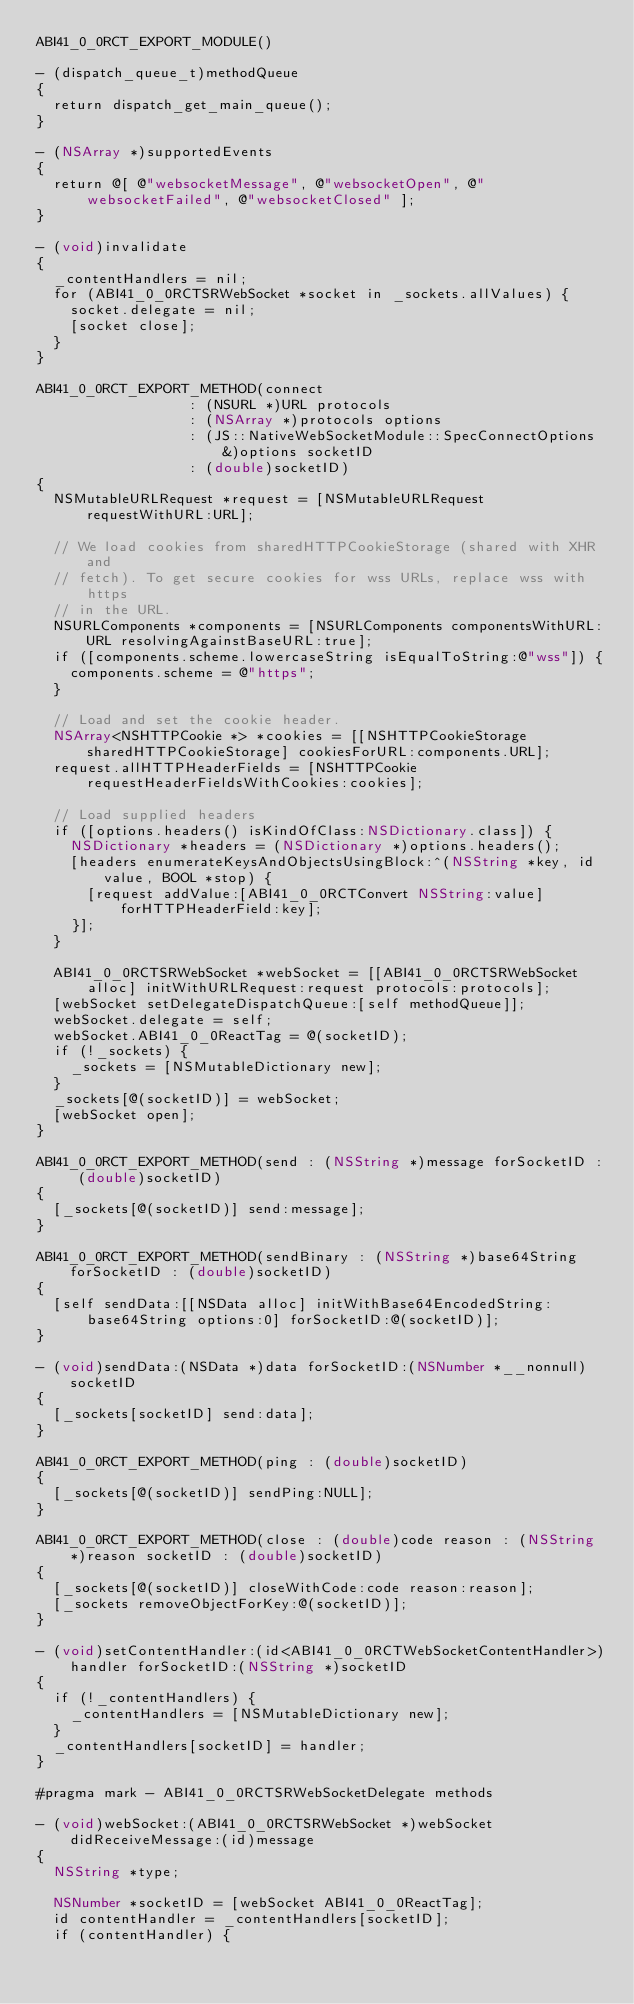Convert code to text. <code><loc_0><loc_0><loc_500><loc_500><_ObjectiveC_>ABI41_0_0RCT_EXPORT_MODULE()

- (dispatch_queue_t)methodQueue
{
  return dispatch_get_main_queue();
}

- (NSArray *)supportedEvents
{
  return @[ @"websocketMessage", @"websocketOpen", @"websocketFailed", @"websocketClosed" ];
}

- (void)invalidate
{
  _contentHandlers = nil;
  for (ABI41_0_0RCTSRWebSocket *socket in _sockets.allValues) {
    socket.delegate = nil;
    [socket close];
  }
}

ABI41_0_0RCT_EXPORT_METHOD(connect
                  : (NSURL *)URL protocols
                  : (NSArray *)protocols options
                  : (JS::NativeWebSocketModule::SpecConnectOptions &)options socketID
                  : (double)socketID)
{
  NSMutableURLRequest *request = [NSMutableURLRequest requestWithURL:URL];

  // We load cookies from sharedHTTPCookieStorage (shared with XHR and
  // fetch). To get secure cookies for wss URLs, replace wss with https
  // in the URL.
  NSURLComponents *components = [NSURLComponents componentsWithURL:URL resolvingAgainstBaseURL:true];
  if ([components.scheme.lowercaseString isEqualToString:@"wss"]) {
    components.scheme = @"https";
  }

  // Load and set the cookie header.
  NSArray<NSHTTPCookie *> *cookies = [[NSHTTPCookieStorage sharedHTTPCookieStorage] cookiesForURL:components.URL];
  request.allHTTPHeaderFields = [NSHTTPCookie requestHeaderFieldsWithCookies:cookies];

  // Load supplied headers
  if ([options.headers() isKindOfClass:NSDictionary.class]) {
    NSDictionary *headers = (NSDictionary *)options.headers();
    [headers enumerateKeysAndObjectsUsingBlock:^(NSString *key, id value, BOOL *stop) {
      [request addValue:[ABI41_0_0RCTConvert NSString:value] forHTTPHeaderField:key];
    }];
  }

  ABI41_0_0RCTSRWebSocket *webSocket = [[ABI41_0_0RCTSRWebSocket alloc] initWithURLRequest:request protocols:protocols];
  [webSocket setDelegateDispatchQueue:[self methodQueue]];
  webSocket.delegate = self;
  webSocket.ABI41_0_0ReactTag = @(socketID);
  if (!_sockets) {
    _sockets = [NSMutableDictionary new];
  }
  _sockets[@(socketID)] = webSocket;
  [webSocket open];
}

ABI41_0_0RCT_EXPORT_METHOD(send : (NSString *)message forSocketID : (double)socketID)
{
  [_sockets[@(socketID)] send:message];
}

ABI41_0_0RCT_EXPORT_METHOD(sendBinary : (NSString *)base64String forSocketID : (double)socketID)
{
  [self sendData:[[NSData alloc] initWithBase64EncodedString:base64String options:0] forSocketID:@(socketID)];
}

- (void)sendData:(NSData *)data forSocketID:(NSNumber *__nonnull)socketID
{
  [_sockets[socketID] send:data];
}

ABI41_0_0RCT_EXPORT_METHOD(ping : (double)socketID)
{
  [_sockets[@(socketID)] sendPing:NULL];
}

ABI41_0_0RCT_EXPORT_METHOD(close : (double)code reason : (NSString *)reason socketID : (double)socketID)
{
  [_sockets[@(socketID)] closeWithCode:code reason:reason];
  [_sockets removeObjectForKey:@(socketID)];
}

- (void)setContentHandler:(id<ABI41_0_0RCTWebSocketContentHandler>)handler forSocketID:(NSString *)socketID
{
  if (!_contentHandlers) {
    _contentHandlers = [NSMutableDictionary new];
  }
  _contentHandlers[socketID] = handler;
}

#pragma mark - ABI41_0_0RCTSRWebSocketDelegate methods

- (void)webSocket:(ABI41_0_0RCTSRWebSocket *)webSocket didReceiveMessage:(id)message
{
  NSString *type;

  NSNumber *socketID = [webSocket ABI41_0_0ReactTag];
  id contentHandler = _contentHandlers[socketID];
  if (contentHandler) {</code> 